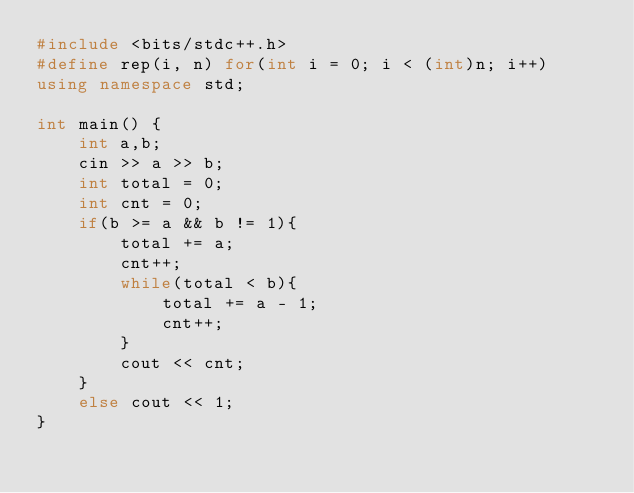Convert code to text. <code><loc_0><loc_0><loc_500><loc_500><_C++_>#include <bits/stdc++.h>
#define rep(i, n) for(int i = 0; i < (int)n; i++)
using namespace std;

int main() {
    int a,b;
    cin >> a >> b;
    int total = 0;
    int cnt = 0;
    if(b >= a && b != 1){
        total += a;
        cnt++;
        while(total < b){
            total += a - 1;
            cnt++;
        }
        cout << cnt;
    }
    else cout << 1;
}
</code> 